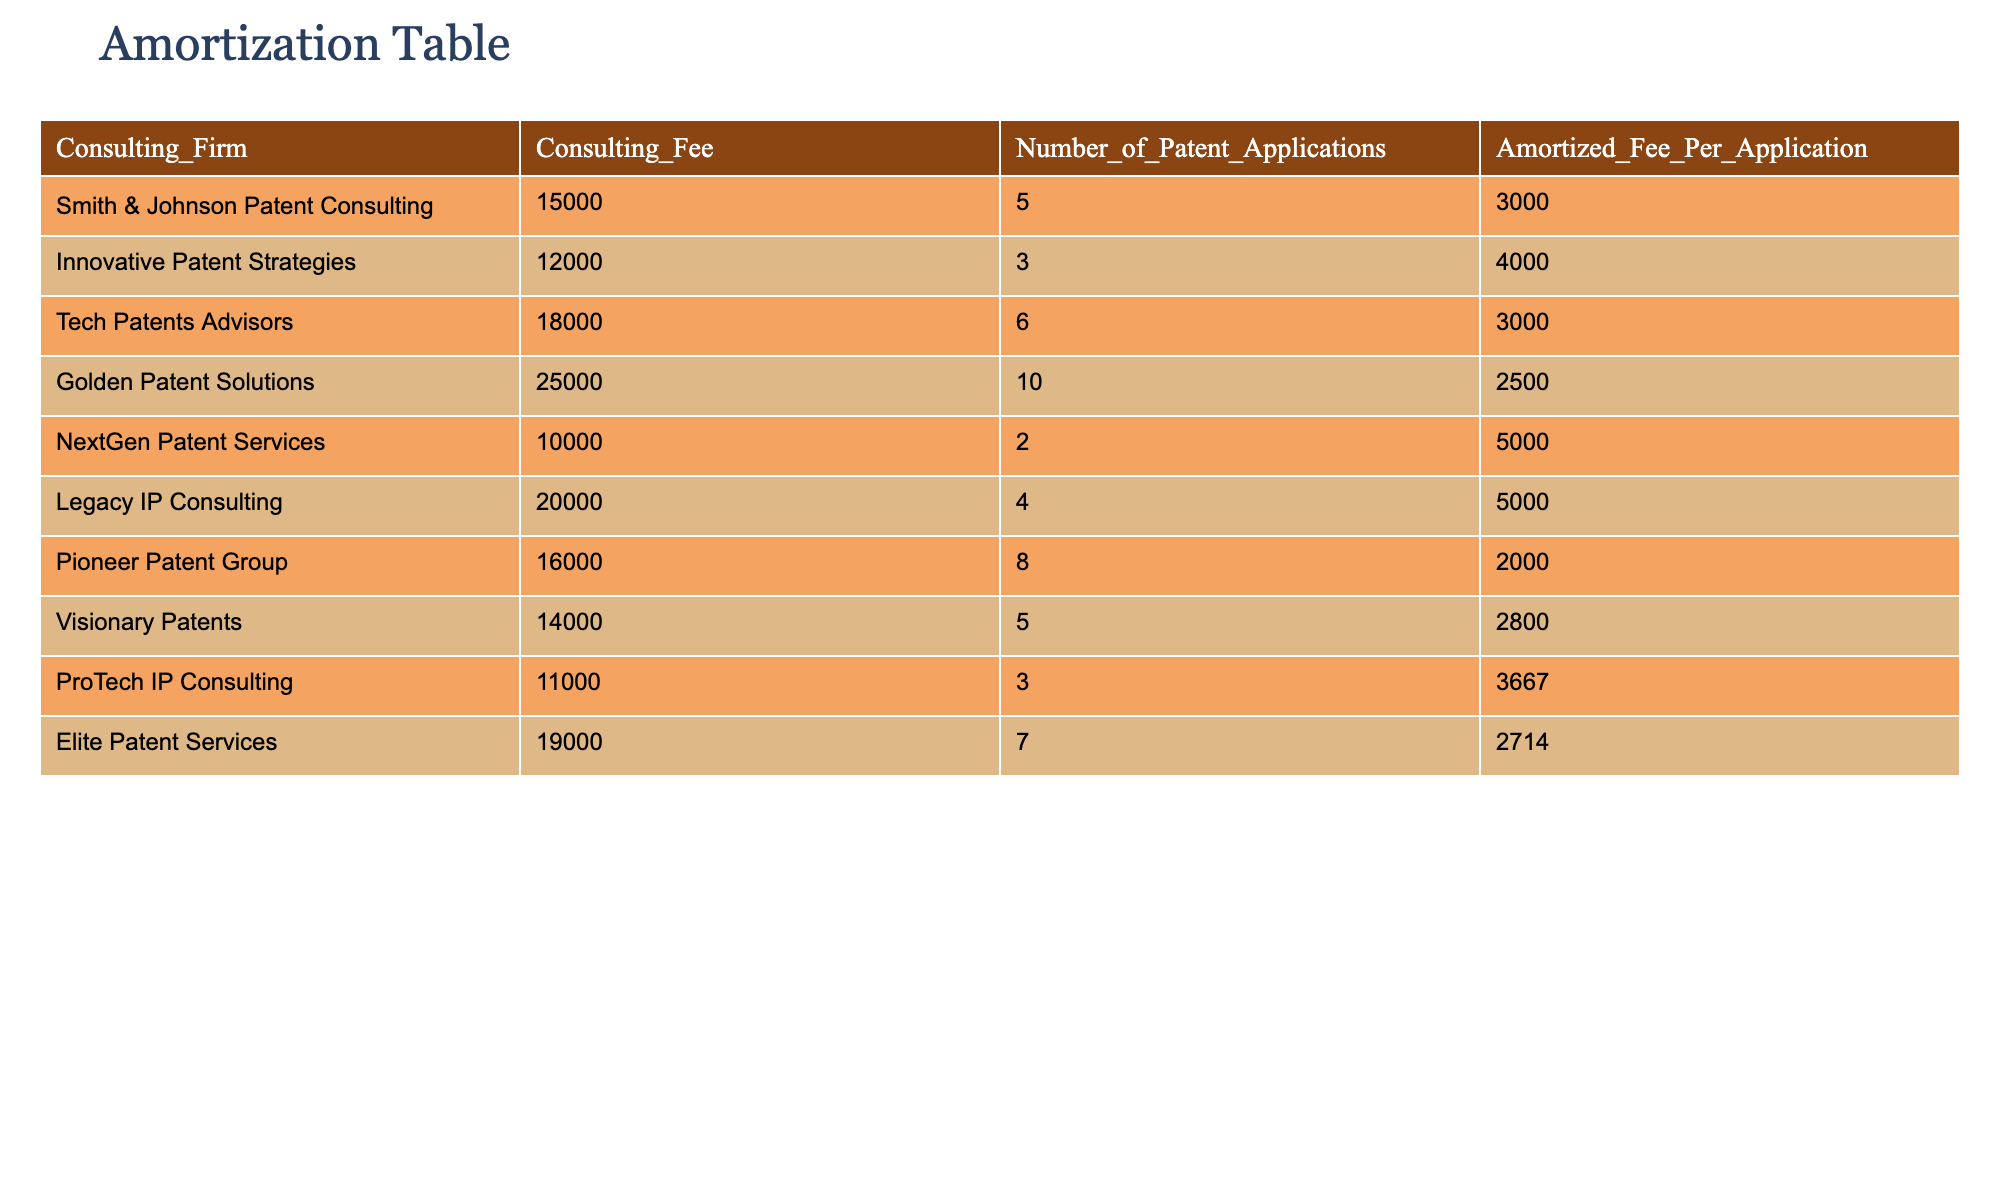What is the total consulting fee charged by Pioneer Patent Group? To find the total consulting fee for Pioneer Patent Group, we look at the corresponding row in the table. The consulting fee listed is 16000.
Answer: 16000 Is the amortized fee per application for Elite Patent Services higher than that of Tech Patents Advisors? The amortized fee for Elite Patent Services is 2714, and for Tech Patents Advisors, it is 3000. Since 2714 is not higher than 3000, the answer is no.
Answer: No What is the average amortized fee per application for all consulting firms? To find the average, we sum all the amortized fees: (3000 + 4000 + 3000 + 2500 + 5000 + 5000 + 2000 + 2800 + 3667 + 2714) = 30,681. There are 10 consulting firms, so we divide 30,681 by 10, which equals 3068.1.
Answer: 3068.1 Which consulting firm has the lowest amortized fee per application? By examining the table, we compare the amortized fee per application for each firm. The lowest amount is 2000, which belongs to Pioneer Patent Group.
Answer: Pioneer Patent Group How many patent applications did Golden Patent Solutions handle? In the table, Golden Patent Solutions has a column indicating the number of patent applications, which is recorded as 10.
Answer: 10 Did NextGen Patent Services charge more or less than the average consulting fee of all firms? First, we calculate the average consulting fee. The fees are 15000, 12000, 18000, 25000, 10000, 20000, 16000, 14000, 11000, and 19000, totaling 1,48000. Dividing this by 10 gives an average of 14800. NextGen's fee is 10000, which is less than 14800. Thus, the answer is yes.
Answer: Yes What is the difference between the highest and lowest amortized fees per application? The highest amortized fee per application is 5000 (for both NextGen Patent Services and Legacy IP Consulting), and the lowest is 2000 (for Pioneer Patent Group). The difference is 5000 - 2000 = 3000.
Answer: 3000 Which consulting firm has the highest consulting fee? By looking at the table, Golden Patent Solutions has the highest consulting fee of 25000.
Answer: Golden Patent Solutions 